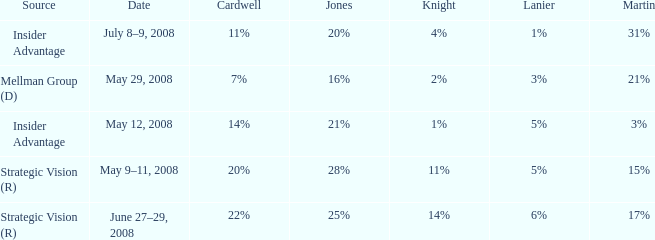What martin is on july 8–9, 2008? 31%. 